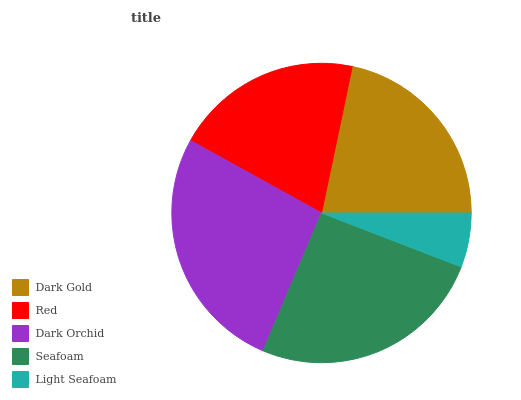Is Light Seafoam the minimum?
Answer yes or no. Yes. Is Dark Orchid the maximum?
Answer yes or no. Yes. Is Red the minimum?
Answer yes or no. No. Is Red the maximum?
Answer yes or no. No. Is Dark Gold greater than Red?
Answer yes or no. Yes. Is Red less than Dark Gold?
Answer yes or no. Yes. Is Red greater than Dark Gold?
Answer yes or no. No. Is Dark Gold less than Red?
Answer yes or no. No. Is Dark Gold the high median?
Answer yes or no. Yes. Is Dark Gold the low median?
Answer yes or no. Yes. Is Light Seafoam the high median?
Answer yes or no. No. Is Dark Orchid the low median?
Answer yes or no. No. 